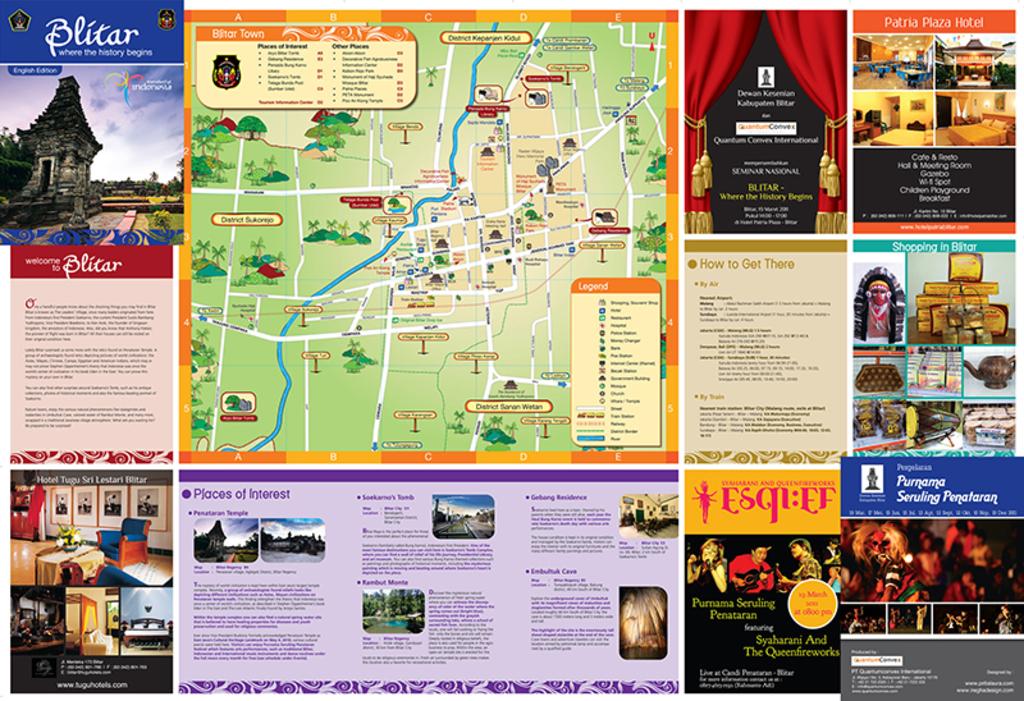What is the bottom right blue ad?
Provide a short and direct response. Unanswerable. What is the first letter on the extreme top left?
Offer a terse response. B. 